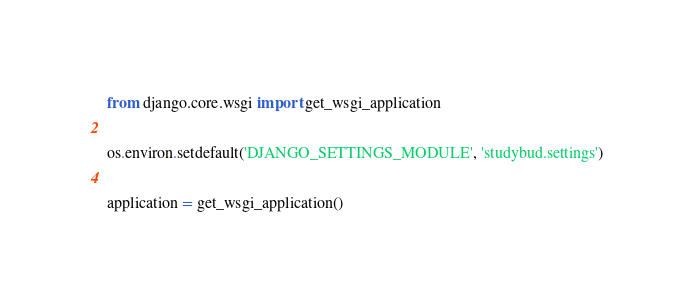<code> <loc_0><loc_0><loc_500><loc_500><_Python_>
from django.core.wsgi import get_wsgi_application

os.environ.setdefault('DJANGO_SETTINGS_MODULE', 'studybud.settings')

application = get_wsgi_application()
</code> 